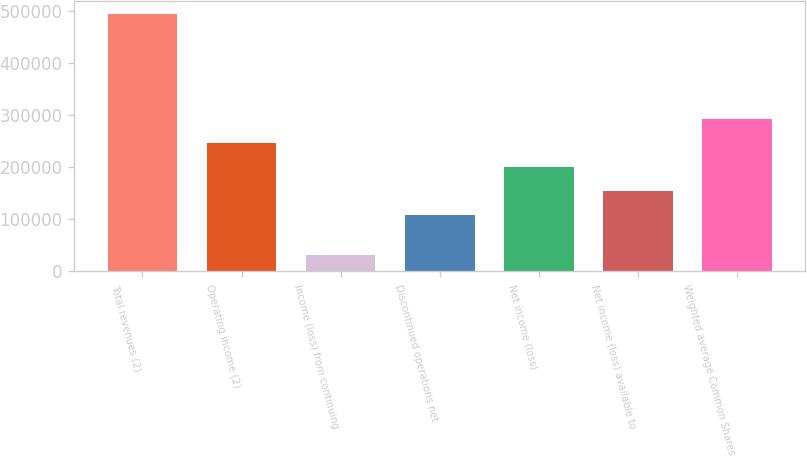<chart> <loc_0><loc_0><loc_500><loc_500><bar_chart><fcel>Total revenues (2)<fcel>Operating income (2)<fcel>Income (loss) from continuing<fcel>Discontinued operations net<fcel>Net income (loss)<fcel>Net income (loss) available to<fcel>Weighted average Common Shares<nl><fcel>493778<fcel>246216<fcel>32239<fcel>107754<fcel>200062<fcel>153908<fcel>292370<nl></chart> 